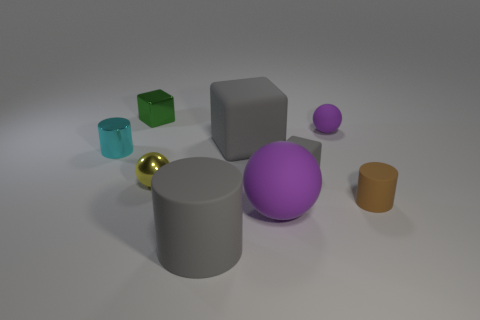There is a cylinder that is to the right of the shiny block and behind the large rubber cylinder; what material is it?
Your answer should be compact. Rubber. Are there any gray cylinders that have the same size as the yellow ball?
Your answer should be compact. No. How many small brown balls are there?
Ensure brevity in your answer.  0. There is a small cyan cylinder; what number of metallic spheres are left of it?
Ensure brevity in your answer.  0. Does the cyan object have the same material as the green block?
Keep it short and to the point. Yes. What number of small rubber things are in front of the tiny cyan metal cylinder and behind the small yellow object?
Your answer should be compact. 1. How many other objects are the same color as the big rubber block?
Offer a terse response. 2. What number of green objects are either large matte cubes or large cylinders?
Ensure brevity in your answer.  0. The brown object has what size?
Offer a very short reply. Small. How many rubber things are large blocks or gray blocks?
Keep it short and to the point. 2. 